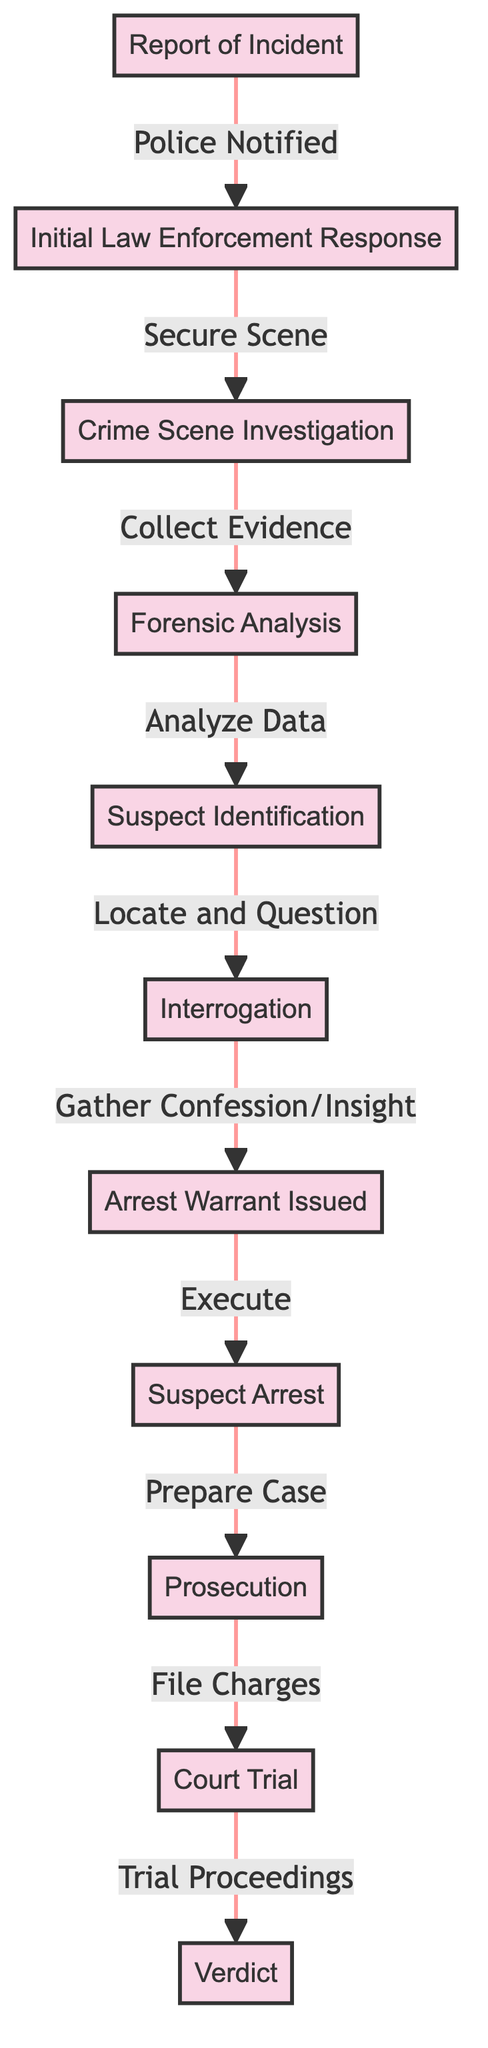What is the first event in the timeline? The first event in the timeline is indicated as "Report of Incident," which is the starting point of the criminal investigation process.
Answer: Report of Incident How many key events are listed in the diagram? By counting the different nodes in the diagram, there are a total of 11 key events listed that detail the progression of a criminal investigation.
Answer: 11 What follows the "Initial Law Enforcement Response"? The node directly connected to "Initial Law Enforcement Response" is "Crime Scene Investigation," which follows as the next step in the process.
Answer: Crime Scene Investigation What action occurs after the "Suspect Identification"? After "Suspect Identification," the subsequent action is "Interrogation," indicating a key step in processing the identified suspect.
Answer: Interrogation What leads to the "Arrest Warrant Issued"? The issuance of an "Arrest Warrant" follows the "Interrogation" event, where insights or confessions are gathered leading to this legal step.
Answer: Interrogation What is the outcome of the "Court Trial"? The final node connected in the diagram is "Verdict," which represents the outcome of the trial proceedings.
Answer: Verdict What action is taken after the "Suspect Arrest"? Following the "Suspect Arrest," the next action in the timeline is "Prosecution," where legal preparations for the case occur.
Answer: Prosecution Which event involves the analysis of evidence? The event labeled "Forensic Analysis" is specifically dedicated to the analysis of evidence collected during the investigation.
Answer: Forensic Analysis How does the "Initial Law Enforcement Response" relate to the "Report of Incident"? The "Initial Law Enforcement Response" is the direct result or action taken after receiving the "Report of Incident," indicating a sequential relationship.
Answer: Police Notified 